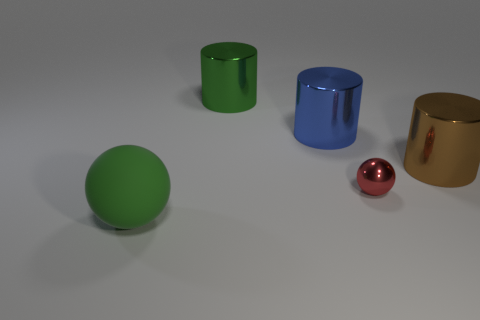Subtract all blue spheres. Subtract all gray blocks. How many spheres are left? 2 Add 2 big brown metallic cylinders. How many objects exist? 7 Subtract all spheres. How many objects are left? 3 Subtract 0 purple cylinders. How many objects are left? 5 Subtract all green metallic cylinders. Subtract all large metallic cylinders. How many objects are left? 1 Add 3 red objects. How many red objects are left? 4 Add 2 green objects. How many green objects exist? 4 